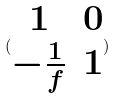<formula> <loc_0><loc_0><loc_500><loc_500>( \begin{matrix} 1 & 0 \\ - \frac { 1 } { f } & 1 \end{matrix} )</formula> 